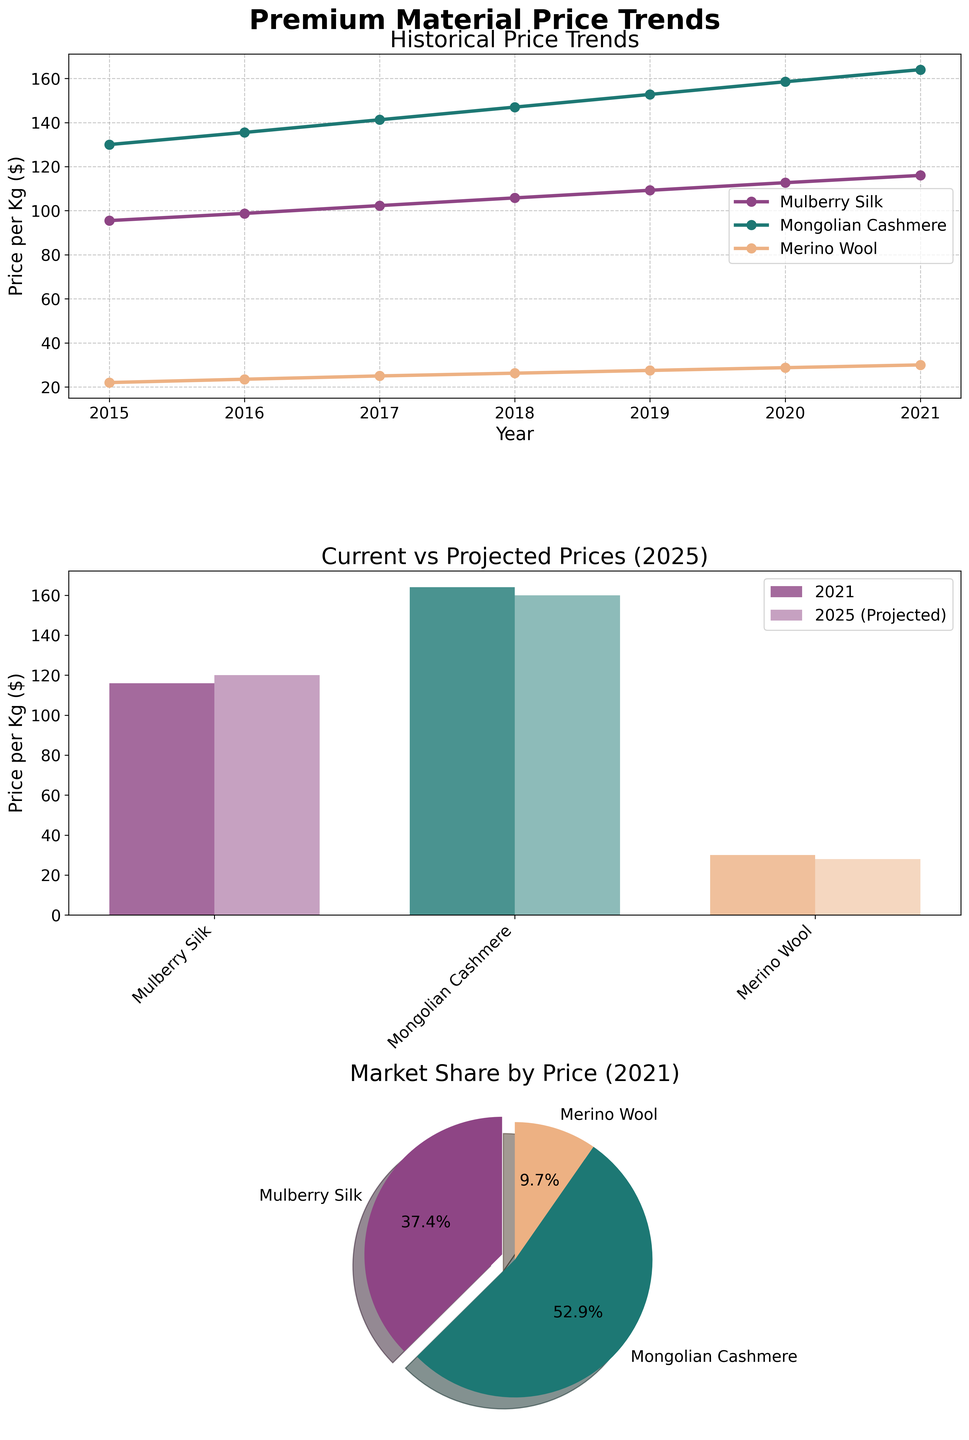What is the main title of the figure? The main title of the figure is located at the top and reads, "Premium Material Price Trends."
Answer: Premium Material Price Trends Which material shows the highest price in 2021? The highest price in 2021 is shown in the line plot and bar plot. According to these plots, Mongolian Cashmere has the highest price in 2021.
Answer: Mongolian Cashmere How do the projected prices for Mulberry Silk in 2025 compare to its prices in 2021? To determine this, we compare Mulberry Silk's price in the 2021 bar (around $116 per kg) with its projected price in 2025 (around $120 per kg). The projected price is slightly higher.
Answer: Slightly higher What percentage of the total 2021 prices does Merino Wool represent? This can be seen from the pie chart. Merino Wool has the smallest slice, representing 11.2% of the total price distribution among the three materials in 2021.
Answer: 11.2% Which material is projected to have the smallest increase in price by 2025? By comparing the 2021 prices with the 2025 projections in the bar plot, Merino Wool is the only material that shows no projected increase from its 2021 price.
Answer: Merino Wool Between 2015 and 2021, which material experienced the most significant price increase? By examining the line plot, it is evident that Mongolian Cashmere had the most significant price increase, starting from $130 in 2015 to $164 in 2021.
Answer: Mongolian Cashmere By how much did the price of Merino Wool increase between 2015 and 2021? Merino Wool's price in 2015 is approximately $22, and in 2021, it is $30. The increase is calculated as $30 - $22 = $8.
Answer: $8 How do the prices of Mulberry Silk and Mongolian Cashmere compare in 2019? From the line plot, we observe that the price of Mulberry Silk in 2019 is around $109.25 per kg, while Mongolian Cashmere is around $152.75 per kg. Mongolian Cashmere is higher.
Answer: Mongolian Cashmere is higher What is the trend in price for Merino Wool from 2020 to 2021, and how does it differ from the other materials? The line plot shows that Merino Wool's price increased from around $28.75 in 2020 to $30 in 2021, while Mulberry Silk and Mongolian Cashmere also increased but at smaller rates than the previous trend years.
Answer: Merino Wool increased faster 